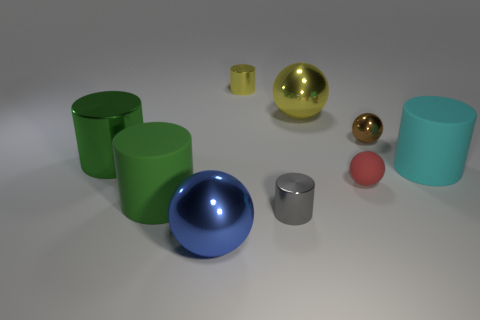Subtract all yellow metallic cylinders. How many cylinders are left? 4 Add 1 small spheres. How many objects exist? 10 Subtract all blue cubes. How many green cylinders are left? 2 Subtract 2 spheres. How many spheres are left? 2 Subtract all blue spheres. How many spheres are left? 3 Subtract all balls. How many objects are left? 5 Subtract all yellow spheres. Subtract all purple cylinders. How many spheres are left? 3 Subtract 1 gray cylinders. How many objects are left? 8 Subtract all big purple metallic things. Subtract all brown things. How many objects are left? 8 Add 8 large rubber objects. How many large rubber objects are left? 10 